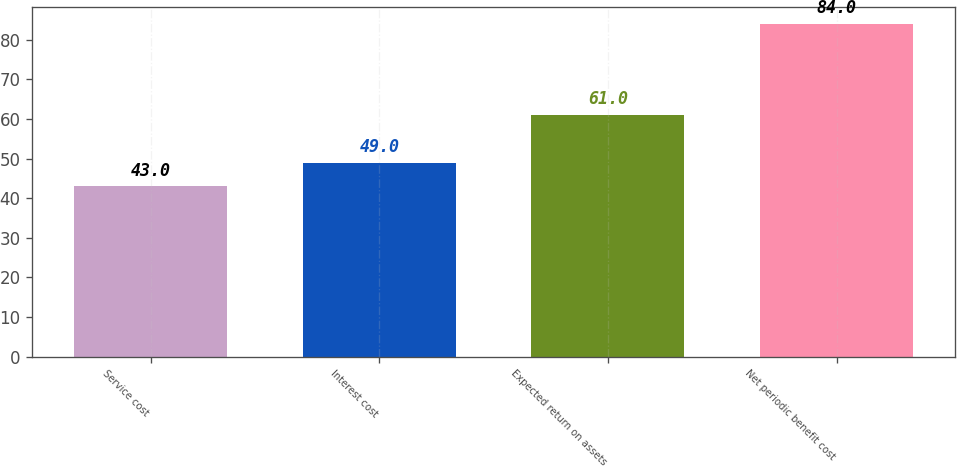Convert chart. <chart><loc_0><loc_0><loc_500><loc_500><bar_chart><fcel>Service cost<fcel>Interest cost<fcel>Expected return on assets<fcel>Net periodic benefit cost<nl><fcel>43<fcel>49<fcel>61<fcel>84<nl></chart> 